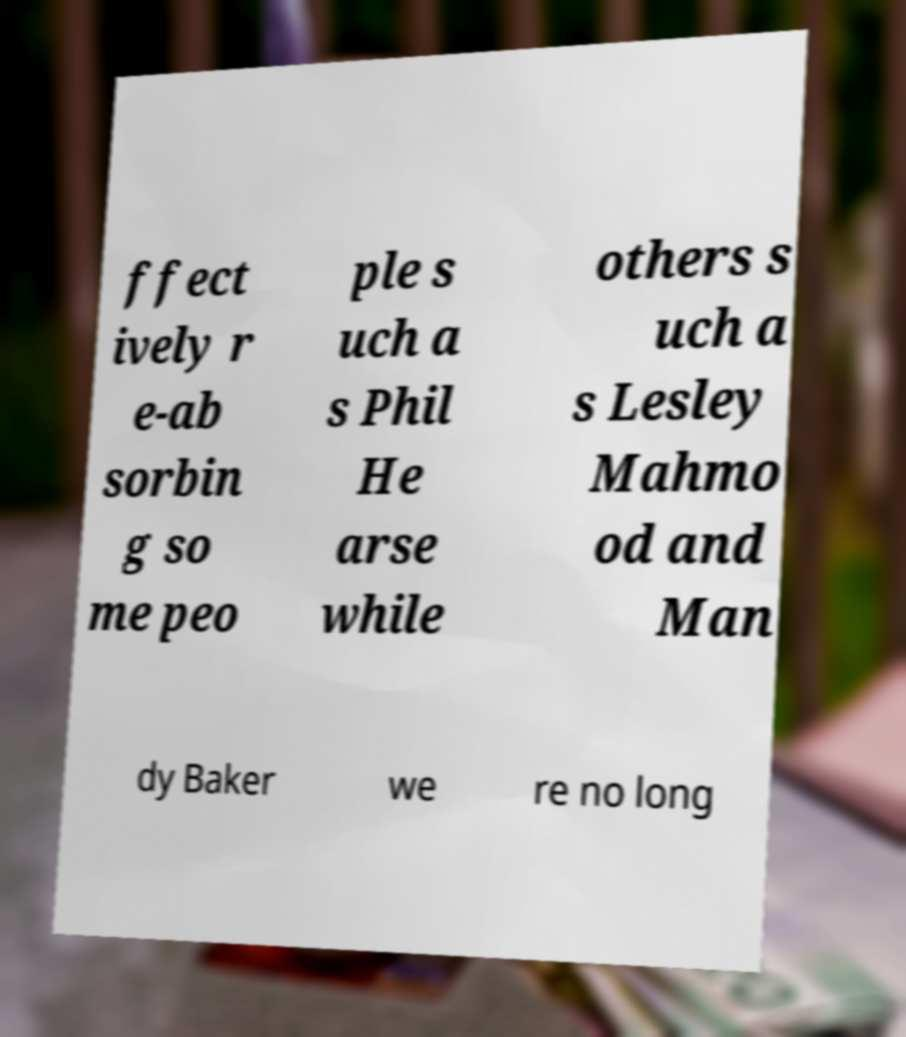For documentation purposes, I need the text within this image transcribed. Could you provide that? ffect ively r e-ab sorbin g so me peo ple s uch a s Phil He arse while others s uch a s Lesley Mahmo od and Man dy Baker we re no long 